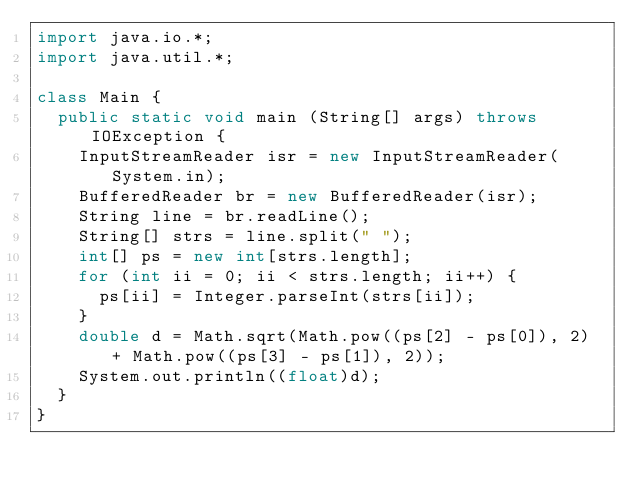<code> <loc_0><loc_0><loc_500><loc_500><_Java_>import java.io.*;
import java.util.*;

class Main {
  public static void main (String[] args) throws IOException {
    InputStreamReader isr = new InputStreamReader(System.in);
    BufferedReader br = new BufferedReader(isr);
    String line = br.readLine();
    String[] strs = line.split(" ");
    int[] ps = new int[strs.length];
    for (int ii = 0; ii < strs.length; ii++) {
      ps[ii] = Integer.parseInt(strs[ii]);
    }
    double d = Math.sqrt(Math.pow((ps[2] - ps[0]), 2) + Math.pow((ps[3] - ps[1]), 2));
    System.out.println((float)d);
  }
}</code> 